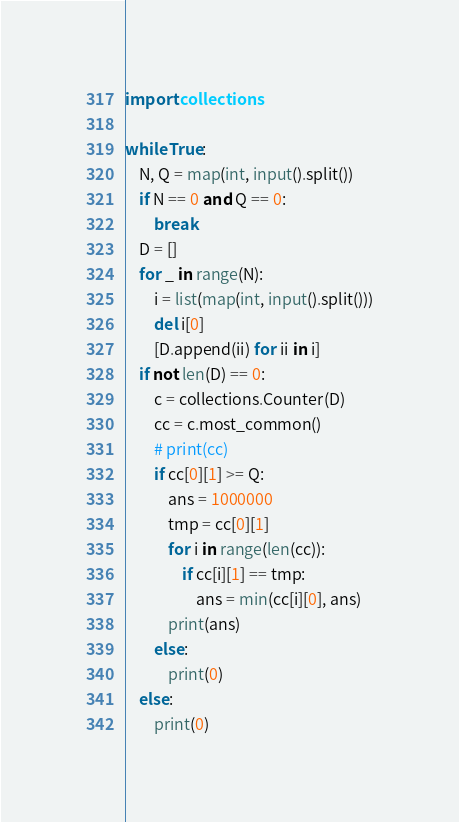<code> <loc_0><loc_0><loc_500><loc_500><_Python_>import collections

while True:
    N, Q = map(int, input().split())
    if N == 0 and Q == 0:
        break
    D = []
    for _ in range(N):
        i = list(map(int, input().split()))
        del i[0]
        [D.append(ii) for ii in i]
    if not len(D) == 0:
        c = collections.Counter(D)
        cc = c.most_common()
        # print(cc)
        if cc[0][1] >= Q:
            ans = 1000000
            tmp = cc[0][1]
            for i in range(len(cc)):
                if cc[i][1] == tmp:
                    ans = min(cc[i][0], ans)
            print(ans)
        else:
            print(0)
    else:
        print(0)

</code> 